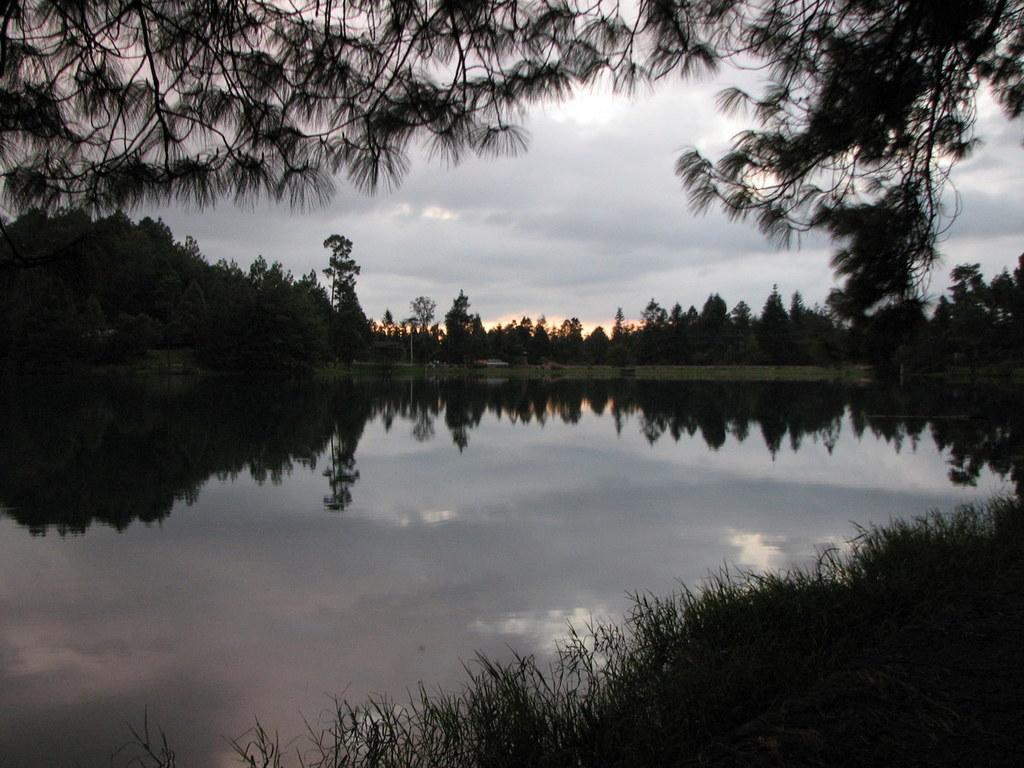Can you describe this image briefly? In this image there are few trees, grass, water and some reflections in the water, a pole and some clouds in the sky. 